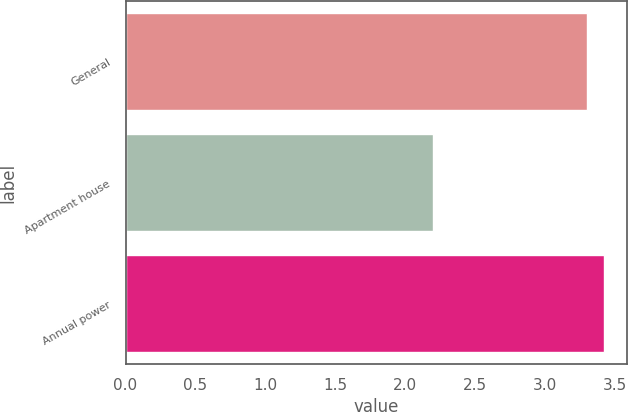Convert chart. <chart><loc_0><loc_0><loc_500><loc_500><bar_chart><fcel>General<fcel>Apartment house<fcel>Annual power<nl><fcel>3.3<fcel>2.2<fcel>3.42<nl></chart> 